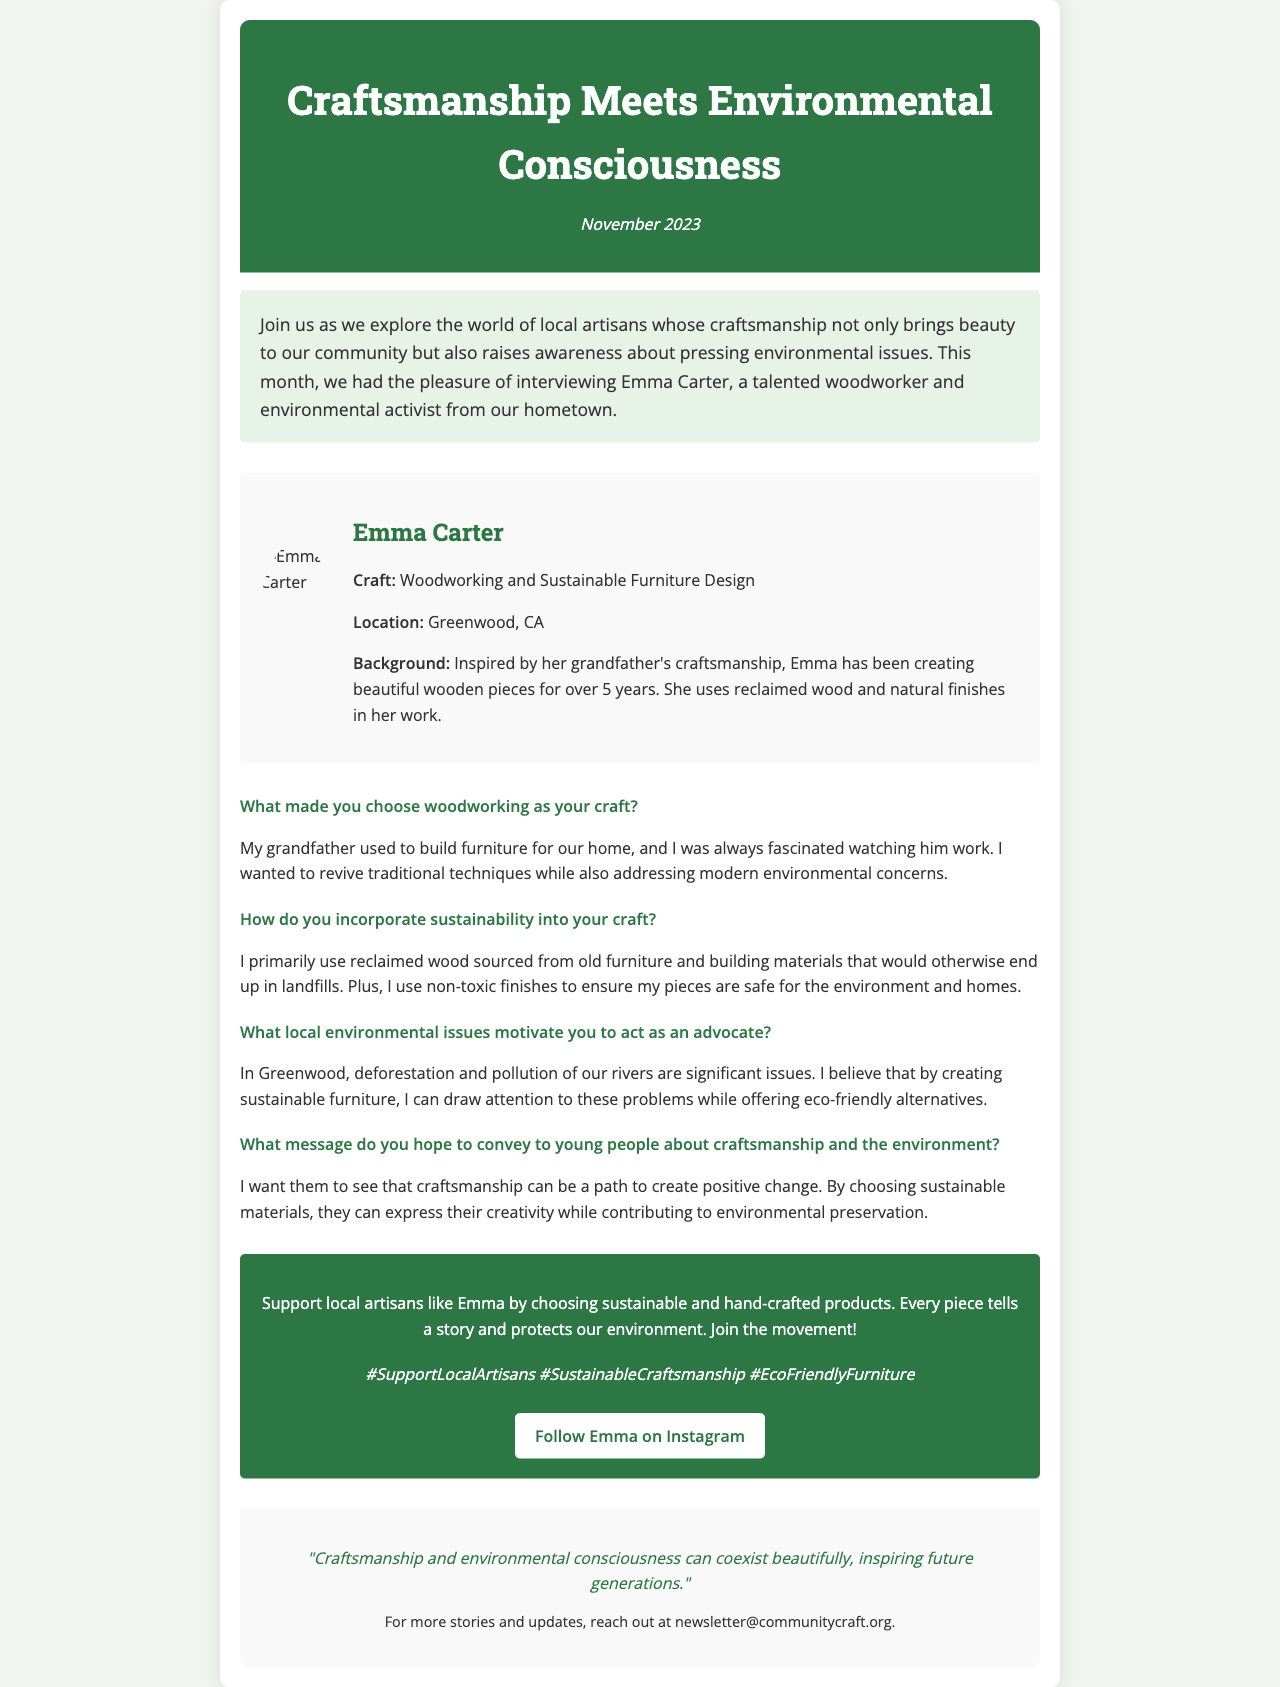What is the name of the artisan featured in the interview? The document explicitly states the artisan's name as Emma Carter.
Answer: Emma Carter What craft does Emma Carter specialize in? The document mentions her specialization as woodworking and sustainable furniture design.
Answer: Woodworking and Sustainable Furniture Design When was this newsletter published? The document shows the date of publication prominently as November 2023.
Answer: November 2023 Which materials does Emma use in her woodworking? According to the document, Emma primarily uses reclaimed wood and non-toxic finishes.
Answer: Reclaimed wood and non-toxic finishes What local environmental issues does Emma advocate for? The document specifies that deforestation and pollution of rivers are significant issues she focuses on.
Answer: Deforestation and pollution of rivers What does Emma hope to convey to young people about craftsmanship? The document indicates she wants young people to see craftsmanship as a way to create positive change through sustainable practices.
Answer: Positive change through sustainable practices How long has Emma been creating wooden pieces? The document states that Emma has been creating wooden pieces for over 5 years.
Answer: Over 5 years What is the call to action in the newsletter? The call to action encourages readers to support local artisans and choose sustainable, hand-crafted products.
Answer: Support local artisans by choosing sustainable and hand-crafted products What quote concludes the newsletter? The concluding quote conveys that craftsmanship and environmental consciousness can coexist beautifully.
Answer: "Craftsmanship and environmental consciousness can coexist beautifully, inspiring future generations." 